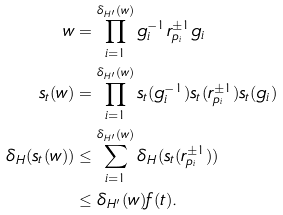<formula> <loc_0><loc_0><loc_500><loc_500>w & = \prod _ { i = 1 } ^ { \delta _ { H ^ { \prime } } ( w ) } g _ { i } ^ { - 1 } r _ { p _ { i } } ^ { \pm 1 } g _ { i } \\ s _ { t } ( w ) & = \prod _ { i = 1 } ^ { \delta _ { H ^ { \prime } } ( w ) } s _ { t } ( g _ { i } ^ { - 1 } ) s _ { t } ( r _ { p _ { i } } ^ { \pm 1 } ) s _ { t } ( g _ { i } ) \\ \delta _ { H } ( s _ { t } ( w ) ) & \leq \sum _ { i = 1 } ^ { \delta _ { H ^ { \prime } } ( w ) } \delta _ { H } ( s _ { t } ( r _ { p _ { i } } ^ { \pm 1 } ) ) \\ & \leq \delta _ { H ^ { \prime } } ( w ) f ( t ) .</formula> 